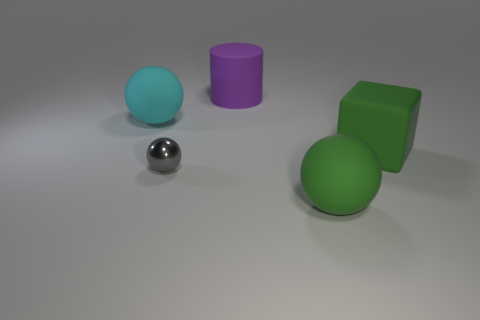Subtract all big spheres. How many spheres are left? 1 Add 4 tiny objects. How many objects exist? 9 Subtract all cylinders. How many objects are left? 4 Subtract 1 balls. How many balls are left? 2 Subtract all purple spheres. Subtract all red cubes. How many spheres are left? 3 Add 4 big red metal spheres. How many big red metal spheres exist? 4 Subtract 0 blue balls. How many objects are left? 5 Subtract all big purple rubber cylinders. Subtract all rubber objects. How many objects are left? 0 Add 2 cyan balls. How many cyan balls are left? 3 